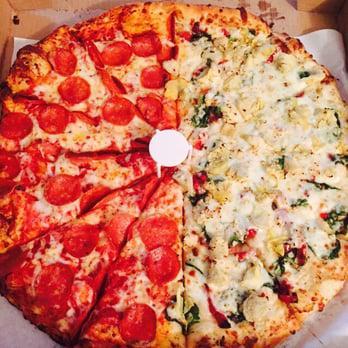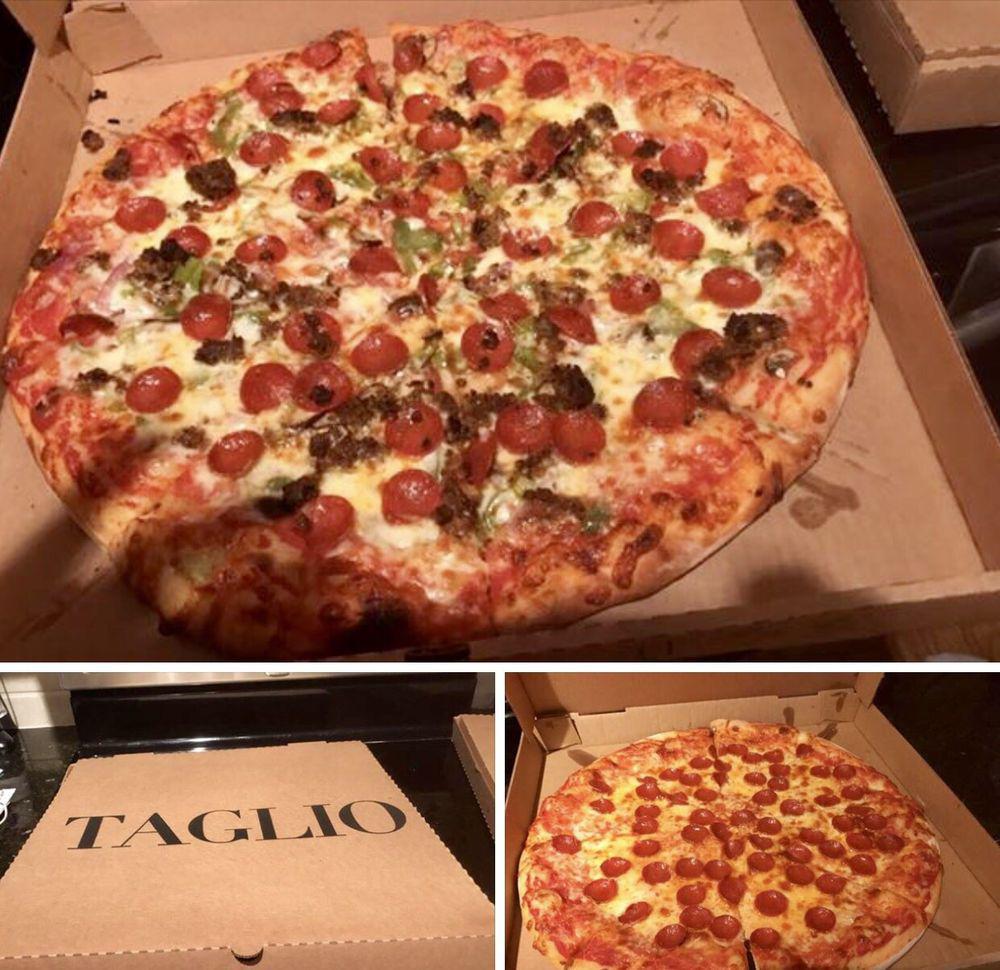The first image is the image on the left, the second image is the image on the right. Given the left and right images, does the statement "A sliced pizza topped with pepperonis and green bits is in an open brown cardboard box in one image." hold true? Answer yes or no. Yes. The first image is the image on the left, the second image is the image on the right. Evaluate the accuracy of this statement regarding the images: "In at least one image there is a a pizza withe pepperoni on each slice that is still in the cardboard box that was delivered.". Is it true? Answer yes or no. Yes. 